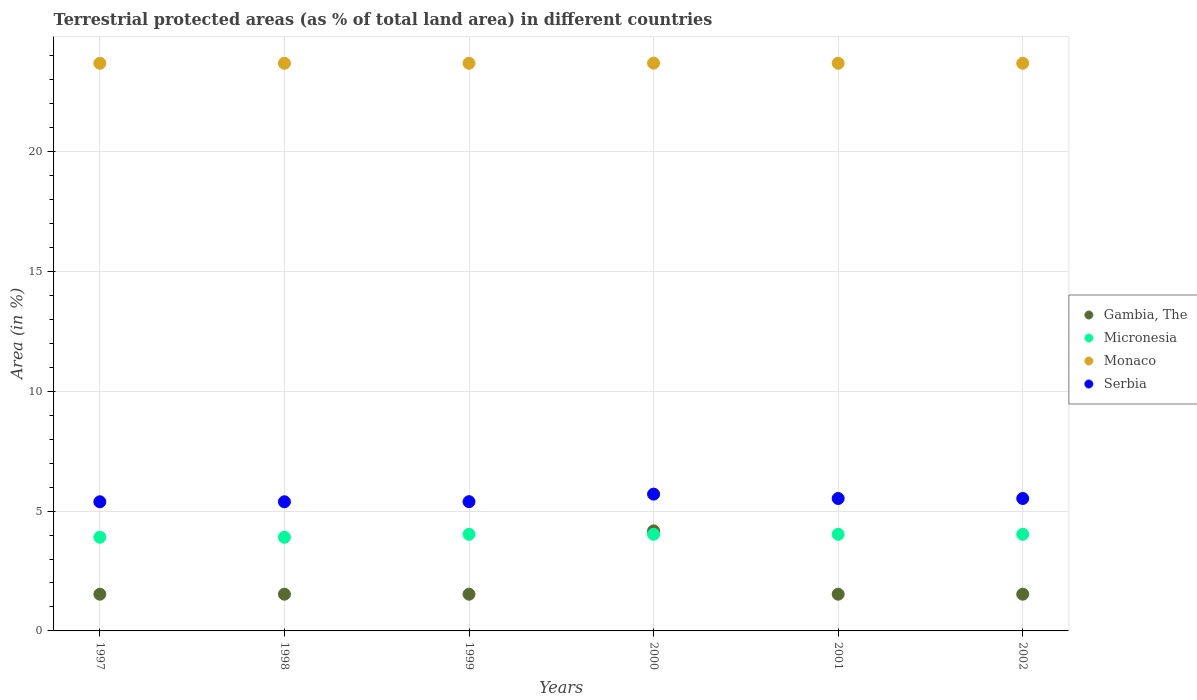What is the percentage of terrestrial protected land in Serbia in 2000?
Provide a short and direct response. 5.71. Across all years, what is the maximum percentage of terrestrial protected land in Micronesia?
Your response must be concise. 4.03. Across all years, what is the minimum percentage of terrestrial protected land in Micronesia?
Your answer should be compact. 3.91. In which year was the percentage of terrestrial protected land in Monaco maximum?
Keep it short and to the point. 2000. What is the total percentage of terrestrial protected land in Gambia, The in the graph?
Give a very brief answer. 11.84. What is the difference between the percentage of terrestrial protected land in Monaco in 2000 and that in 2001?
Provide a succinct answer. 0.01. What is the difference between the percentage of terrestrial protected land in Monaco in 1998 and the percentage of terrestrial protected land in Micronesia in 2002?
Ensure brevity in your answer.  19.65. What is the average percentage of terrestrial protected land in Monaco per year?
Give a very brief answer. 23.69. In the year 2001, what is the difference between the percentage of terrestrial protected land in Monaco and percentage of terrestrial protected land in Gambia, The?
Make the answer very short. 22.15. What is the ratio of the percentage of terrestrial protected land in Serbia in 1998 to that in 2000?
Make the answer very short. 0.94. Is the percentage of terrestrial protected land in Monaco in 1997 less than that in 2001?
Offer a terse response. No. Is the difference between the percentage of terrestrial protected land in Monaco in 1997 and 1998 greater than the difference between the percentage of terrestrial protected land in Gambia, The in 1997 and 1998?
Provide a short and direct response. No. What is the difference between the highest and the second highest percentage of terrestrial protected land in Gambia, The?
Offer a terse response. 2.64. What is the difference between the highest and the lowest percentage of terrestrial protected land in Serbia?
Your answer should be very brief. 0.32. In how many years, is the percentage of terrestrial protected land in Monaco greater than the average percentage of terrestrial protected land in Monaco taken over all years?
Give a very brief answer. 1. Is the sum of the percentage of terrestrial protected land in Micronesia in 1999 and 2001 greater than the maximum percentage of terrestrial protected land in Monaco across all years?
Provide a short and direct response. No. Is the percentage of terrestrial protected land in Serbia strictly less than the percentage of terrestrial protected land in Gambia, The over the years?
Give a very brief answer. No. How many dotlines are there?
Your answer should be very brief. 4. Does the graph contain any zero values?
Offer a very short reply. No. How are the legend labels stacked?
Provide a succinct answer. Vertical. What is the title of the graph?
Ensure brevity in your answer.  Terrestrial protected areas (as % of total land area) in different countries. Does "Egypt, Arab Rep." appear as one of the legend labels in the graph?
Offer a terse response. No. What is the label or title of the X-axis?
Offer a terse response. Years. What is the label or title of the Y-axis?
Keep it short and to the point. Area (in %). What is the Area (in %) in Gambia, The in 1997?
Your response must be concise. 1.53. What is the Area (in %) of Micronesia in 1997?
Your answer should be compact. 3.91. What is the Area (in %) in Monaco in 1997?
Your answer should be very brief. 23.68. What is the Area (in %) in Serbia in 1997?
Provide a short and direct response. 5.39. What is the Area (in %) of Gambia, The in 1998?
Provide a succinct answer. 1.53. What is the Area (in %) in Micronesia in 1998?
Keep it short and to the point. 3.91. What is the Area (in %) in Monaco in 1998?
Give a very brief answer. 23.68. What is the Area (in %) of Serbia in 1998?
Provide a succinct answer. 5.39. What is the Area (in %) in Gambia, The in 1999?
Your answer should be very brief. 1.53. What is the Area (in %) of Micronesia in 1999?
Give a very brief answer. 4.03. What is the Area (in %) of Monaco in 1999?
Your answer should be very brief. 23.68. What is the Area (in %) in Serbia in 1999?
Your response must be concise. 5.39. What is the Area (in %) of Gambia, The in 2000?
Your answer should be very brief. 4.17. What is the Area (in %) in Micronesia in 2000?
Provide a short and direct response. 4.03. What is the Area (in %) in Monaco in 2000?
Offer a terse response. 23.69. What is the Area (in %) in Serbia in 2000?
Your answer should be very brief. 5.71. What is the Area (in %) of Gambia, The in 2001?
Provide a succinct answer. 1.53. What is the Area (in %) in Micronesia in 2001?
Your response must be concise. 4.03. What is the Area (in %) in Monaco in 2001?
Offer a terse response. 23.68. What is the Area (in %) of Serbia in 2001?
Provide a succinct answer. 5.53. What is the Area (in %) in Gambia, The in 2002?
Provide a short and direct response. 1.53. What is the Area (in %) of Micronesia in 2002?
Provide a succinct answer. 4.03. What is the Area (in %) of Monaco in 2002?
Offer a terse response. 23.68. What is the Area (in %) of Serbia in 2002?
Provide a succinct answer. 5.53. Across all years, what is the maximum Area (in %) of Gambia, The?
Your response must be concise. 4.17. Across all years, what is the maximum Area (in %) of Micronesia?
Your answer should be very brief. 4.03. Across all years, what is the maximum Area (in %) of Monaco?
Your answer should be compact. 23.69. Across all years, what is the maximum Area (in %) of Serbia?
Ensure brevity in your answer.  5.71. Across all years, what is the minimum Area (in %) in Gambia, The?
Ensure brevity in your answer.  1.53. Across all years, what is the minimum Area (in %) in Micronesia?
Offer a very short reply. 3.91. Across all years, what is the minimum Area (in %) in Monaco?
Make the answer very short. 23.68. Across all years, what is the minimum Area (in %) of Serbia?
Give a very brief answer. 5.39. What is the total Area (in %) of Gambia, The in the graph?
Keep it short and to the point. 11.84. What is the total Area (in %) of Micronesia in the graph?
Keep it short and to the point. 23.94. What is the total Area (in %) in Monaco in the graph?
Make the answer very short. 142.11. What is the total Area (in %) of Serbia in the graph?
Provide a short and direct response. 32.93. What is the difference between the Area (in %) of Serbia in 1997 and that in 1998?
Keep it short and to the point. -0. What is the difference between the Area (in %) in Micronesia in 1997 and that in 1999?
Make the answer very short. -0.12. What is the difference between the Area (in %) of Monaco in 1997 and that in 1999?
Ensure brevity in your answer.  0. What is the difference between the Area (in %) in Serbia in 1997 and that in 1999?
Ensure brevity in your answer.  -0. What is the difference between the Area (in %) in Gambia, The in 1997 and that in 2000?
Provide a short and direct response. -2.64. What is the difference between the Area (in %) of Micronesia in 1997 and that in 2000?
Ensure brevity in your answer.  -0.12. What is the difference between the Area (in %) in Monaco in 1997 and that in 2000?
Ensure brevity in your answer.  -0.01. What is the difference between the Area (in %) of Serbia in 1997 and that in 2000?
Your answer should be compact. -0.32. What is the difference between the Area (in %) in Gambia, The in 1997 and that in 2001?
Ensure brevity in your answer.  0. What is the difference between the Area (in %) in Micronesia in 1997 and that in 2001?
Keep it short and to the point. -0.12. What is the difference between the Area (in %) of Serbia in 1997 and that in 2001?
Offer a very short reply. -0.14. What is the difference between the Area (in %) of Gambia, The in 1997 and that in 2002?
Make the answer very short. 0. What is the difference between the Area (in %) of Micronesia in 1997 and that in 2002?
Your response must be concise. -0.12. What is the difference between the Area (in %) of Serbia in 1997 and that in 2002?
Offer a terse response. -0.14. What is the difference between the Area (in %) of Micronesia in 1998 and that in 1999?
Offer a very short reply. -0.12. What is the difference between the Area (in %) in Monaco in 1998 and that in 1999?
Ensure brevity in your answer.  0. What is the difference between the Area (in %) of Serbia in 1998 and that in 1999?
Make the answer very short. -0. What is the difference between the Area (in %) of Gambia, The in 1998 and that in 2000?
Your response must be concise. -2.64. What is the difference between the Area (in %) of Micronesia in 1998 and that in 2000?
Your response must be concise. -0.12. What is the difference between the Area (in %) in Monaco in 1998 and that in 2000?
Provide a short and direct response. -0.01. What is the difference between the Area (in %) in Serbia in 1998 and that in 2000?
Ensure brevity in your answer.  -0.32. What is the difference between the Area (in %) of Micronesia in 1998 and that in 2001?
Keep it short and to the point. -0.12. What is the difference between the Area (in %) of Monaco in 1998 and that in 2001?
Offer a very short reply. 0. What is the difference between the Area (in %) of Serbia in 1998 and that in 2001?
Keep it short and to the point. -0.14. What is the difference between the Area (in %) in Micronesia in 1998 and that in 2002?
Give a very brief answer. -0.12. What is the difference between the Area (in %) of Monaco in 1998 and that in 2002?
Ensure brevity in your answer.  0. What is the difference between the Area (in %) in Serbia in 1998 and that in 2002?
Offer a terse response. -0.14. What is the difference between the Area (in %) in Gambia, The in 1999 and that in 2000?
Your response must be concise. -2.64. What is the difference between the Area (in %) of Monaco in 1999 and that in 2000?
Your answer should be compact. -0.01. What is the difference between the Area (in %) of Serbia in 1999 and that in 2000?
Offer a terse response. -0.31. What is the difference between the Area (in %) of Gambia, The in 1999 and that in 2001?
Provide a short and direct response. 0. What is the difference between the Area (in %) in Monaco in 1999 and that in 2001?
Ensure brevity in your answer.  0. What is the difference between the Area (in %) in Serbia in 1999 and that in 2001?
Make the answer very short. -0.13. What is the difference between the Area (in %) in Gambia, The in 1999 and that in 2002?
Your response must be concise. 0. What is the difference between the Area (in %) of Serbia in 1999 and that in 2002?
Ensure brevity in your answer.  -0.13. What is the difference between the Area (in %) in Gambia, The in 2000 and that in 2001?
Offer a terse response. 2.64. What is the difference between the Area (in %) in Micronesia in 2000 and that in 2001?
Your response must be concise. -0. What is the difference between the Area (in %) of Monaco in 2000 and that in 2001?
Make the answer very short. 0.01. What is the difference between the Area (in %) in Serbia in 2000 and that in 2001?
Provide a short and direct response. 0.18. What is the difference between the Area (in %) in Gambia, The in 2000 and that in 2002?
Your response must be concise. 2.64. What is the difference between the Area (in %) in Micronesia in 2000 and that in 2002?
Keep it short and to the point. -0. What is the difference between the Area (in %) of Monaco in 2000 and that in 2002?
Keep it short and to the point. 0.01. What is the difference between the Area (in %) in Serbia in 2000 and that in 2002?
Offer a very short reply. 0.18. What is the difference between the Area (in %) in Monaco in 2001 and that in 2002?
Provide a succinct answer. 0. What is the difference between the Area (in %) in Gambia, The in 1997 and the Area (in %) in Micronesia in 1998?
Your answer should be very brief. -2.38. What is the difference between the Area (in %) in Gambia, The in 1997 and the Area (in %) in Monaco in 1998?
Your response must be concise. -22.15. What is the difference between the Area (in %) of Gambia, The in 1997 and the Area (in %) of Serbia in 1998?
Give a very brief answer. -3.86. What is the difference between the Area (in %) in Micronesia in 1997 and the Area (in %) in Monaco in 1998?
Offer a very short reply. -19.78. What is the difference between the Area (in %) of Micronesia in 1997 and the Area (in %) of Serbia in 1998?
Keep it short and to the point. -1.48. What is the difference between the Area (in %) in Monaco in 1997 and the Area (in %) in Serbia in 1998?
Your response must be concise. 18.3. What is the difference between the Area (in %) of Gambia, The in 1997 and the Area (in %) of Micronesia in 1999?
Make the answer very short. -2.5. What is the difference between the Area (in %) in Gambia, The in 1997 and the Area (in %) in Monaco in 1999?
Make the answer very short. -22.15. What is the difference between the Area (in %) of Gambia, The in 1997 and the Area (in %) of Serbia in 1999?
Offer a very short reply. -3.86. What is the difference between the Area (in %) in Micronesia in 1997 and the Area (in %) in Monaco in 1999?
Ensure brevity in your answer.  -19.78. What is the difference between the Area (in %) of Micronesia in 1997 and the Area (in %) of Serbia in 1999?
Provide a succinct answer. -1.48. What is the difference between the Area (in %) of Monaco in 1997 and the Area (in %) of Serbia in 1999?
Provide a short and direct response. 18.29. What is the difference between the Area (in %) in Gambia, The in 1997 and the Area (in %) in Micronesia in 2000?
Your response must be concise. -2.5. What is the difference between the Area (in %) of Gambia, The in 1997 and the Area (in %) of Monaco in 2000?
Your response must be concise. -22.16. What is the difference between the Area (in %) in Gambia, The in 1997 and the Area (in %) in Serbia in 2000?
Ensure brevity in your answer.  -4.18. What is the difference between the Area (in %) in Micronesia in 1997 and the Area (in %) in Monaco in 2000?
Provide a short and direct response. -19.78. What is the difference between the Area (in %) in Micronesia in 1997 and the Area (in %) in Serbia in 2000?
Provide a short and direct response. -1.8. What is the difference between the Area (in %) of Monaco in 1997 and the Area (in %) of Serbia in 2000?
Provide a short and direct response. 17.98. What is the difference between the Area (in %) of Gambia, The in 1997 and the Area (in %) of Micronesia in 2001?
Provide a short and direct response. -2.5. What is the difference between the Area (in %) of Gambia, The in 1997 and the Area (in %) of Monaco in 2001?
Your answer should be compact. -22.15. What is the difference between the Area (in %) in Gambia, The in 1997 and the Area (in %) in Serbia in 2001?
Give a very brief answer. -3.99. What is the difference between the Area (in %) in Micronesia in 1997 and the Area (in %) in Monaco in 2001?
Offer a terse response. -19.78. What is the difference between the Area (in %) in Micronesia in 1997 and the Area (in %) in Serbia in 2001?
Your answer should be compact. -1.62. What is the difference between the Area (in %) of Monaco in 1997 and the Area (in %) of Serbia in 2001?
Ensure brevity in your answer.  18.16. What is the difference between the Area (in %) in Gambia, The in 1997 and the Area (in %) in Micronesia in 2002?
Offer a very short reply. -2.5. What is the difference between the Area (in %) in Gambia, The in 1997 and the Area (in %) in Monaco in 2002?
Give a very brief answer. -22.15. What is the difference between the Area (in %) of Gambia, The in 1997 and the Area (in %) of Serbia in 2002?
Offer a terse response. -3.99. What is the difference between the Area (in %) of Micronesia in 1997 and the Area (in %) of Monaco in 2002?
Your response must be concise. -19.78. What is the difference between the Area (in %) of Micronesia in 1997 and the Area (in %) of Serbia in 2002?
Ensure brevity in your answer.  -1.62. What is the difference between the Area (in %) in Monaco in 1997 and the Area (in %) in Serbia in 2002?
Give a very brief answer. 18.16. What is the difference between the Area (in %) in Gambia, The in 1998 and the Area (in %) in Micronesia in 1999?
Offer a terse response. -2.5. What is the difference between the Area (in %) in Gambia, The in 1998 and the Area (in %) in Monaco in 1999?
Your answer should be very brief. -22.15. What is the difference between the Area (in %) in Gambia, The in 1998 and the Area (in %) in Serbia in 1999?
Provide a succinct answer. -3.86. What is the difference between the Area (in %) of Micronesia in 1998 and the Area (in %) of Monaco in 1999?
Keep it short and to the point. -19.78. What is the difference between the Area (in %) in Micronesia in 1998 and the Area (in %) in Serbia in 1999?
Offer a very short reply. -1.48. What is the difference between the Area (in %) in Monaco in 1998 and the Area (in %) in Serbia in 1999?
Keep it short and to the point. 18.29. What is the difference between the Area (in %) of Gambia, The in 1998 and the Area (in %) of Micronesia in 2000?
Ensure brevity in your answer.  -2.5. What is the difference between the Area (in %) in Gambia, The in 1998 and the Area (in %) in Monaco in 2000?
Offer a terse response. -22.16. What is the difference between the Area (in %) in Gambia, The in 1998 and the Area (in %) in Serbia in 2000?
Keep it short and to the point. -4.18. What is the difference between the Area (in %) in Micronesia in 1998 and the Area (in %) in Monaco in 2000?
Make the answer very short. -19.78. What is the difference between the Area (in %) of Micronesia in 1998 and the Area (in %) of Serbia in 2000?
Ensure brevity in your answer.  -1.8. What is the difference between the Area (in %) of Monaco in 1998 and the Area (in %) of Serbia in 2000?
Your answer should be very brief. 17.98. What is the difference between the Area (in %) of Gambia, The in 1998 and the Area (in %) of Micronesia in 2001?
Provide a short and direct response. -2.5. What is the difference between the Area (in %) in Gambia, The in 1998 and the Area (in %) in Monaco in 2001?
Offer a terse response. -22.15. What is the difference between the Area (in %) in Gambia, The in 1998 and the Area (in %) in Serbia in 2001?
Provide a succinct answer. -3.99. What is the difference between the Area (in %) in Micronesia in 1998 and the Area (in %) in Monaco in 2001?
Keep it short and to the point. -19.78. What is the difference between the Area (in %) in Micronesia in 1998 and the Area (in %) in Serbia in 2001?
Your answer should be compact. -1.62. What is the difference between the Area (in %) of Monaco in 1998 and the Area (in %) of Serbia in 2001?
Your answer should be compact. 18.16. What is the difference between the Area (in %) of Gambia, The in 1998 and the Area (in %) of Micronesia in 2002?
Your answer should be very brief. -2.5. What is the difference between the Area (in %) in Gambia, The in 1998 and the Area (in %) in Monaco in 2002?
Ensure brevity in your answer.  -22.15. What is the difference between the Area (in %) in Gambia, The in 1998 and the Area (in %) in Serbia in 2002?
Your answer should be compact. -3.99. What is the difference between the Area (in %) of Micronesia in 1998 and the Area (in %) of Monaco in 2002?
Make the answer very short. -19.78. What is the difference between the Area (in %) of Micronesia in 1998 and the Area (in %) of Serbia in 2002?
Keep it short and to the point. -1.62. What is the difference between the Area (in %) in Monaco in 1998 and the Area (in %) in Serbia in 2002?
Your answer should be compact. 18.16. What is the difference between the Area (in %) in Gambia, The in 1999 and the Area (in %) in Micronesia in 2000?
Keep it short and to the point. -2.5. What is the difference between the Area (in %) in Gambia, The in 1999 and the Area (in %) in Monaco in 2000?
Your answer should be very brief. -22.16. What is the difference between the Area (in %) of Gambia, The in 1999 and the Area (in %) of Serbia in 2000?
Your answer should be very brief. -4.18. What is the difference between the Area (in %) of Micronesia in 1999 and the Area (in %) of Monaco in 2000?
Your answer should be compact. -19.66. What is the difference between the Area (in %) in Micronesia in 1999 and the Area (in %) in Serbia in 2000?
Provide a succinct answer. -1.68. What is the difference between the Area (in %) of Monaco in 1999 and the Area (in %) of Serbia in 2000?
Offer a very short reply. 17.98. What is the difference between the Area (in %) in Gambia, The in 1999 and the Area (in %) in Micronesia in 2001?
Provide a succinct answer. -2.5. What is the difference between the Area (in %) in Gambia, The in 1999 and the Area (in %) in Monaco in 2001?
Your answer should be compact. -22.15. What is the difference between the Area (in %) of Gambia, The in 1999 and the Area (in %) of Serbia in 2001?
Offer a terse response. -3.99. What is the difference between the Area (in %) in Micronesia in 1999 and the Area (in %) in Monaco in 2001?
Offer a very short reply. -19.65. What is the difference between the Area (in %) in Micronesia in 1999 and the Area (in %) in Serbia in 2001?
Provide a succinct answer. -1.49. What is the difference between the Area (in %) of Monaco in 1999 and the Area (in %) of Serbia in 2001?
Give a very brief answer. 18.16. What is the difference between the Area (in %) of Gambia, The in 1999 and the Area (in %) of Micronesia in 2002?
Make the answer very short. -2.5. What is the difference between the Area (in %) in Gambia, The in 1999 and the Area (in %) in Monaco in 2002?
Your response must be concise. -22.15. What is the difference between the Area (in %) in Gambia, The in 1999 and the Area (in %) in Serbia in 2002?
Ensure brevity in your answer.  -3.99. What is the difference between the Area (in %) of Micronesia in 1999 and the Area (in %) of Monaco in 2002?
Ensure brevity in your answer.  -19.65. What is the difference between the Area (in %) of Micronesia in 1999 and the Area (in %) of Serbia in 2002?
Your answer should be very brief. -1.49. What is the difference between the Area (in %) of Monaco in 1999 and the Area (in %) of Serbia in 2002?
Ensure brevity in your answer.  18.16. What is the difference between the Area (in %) in Gambia, The in 2000 and the Area (in %) in Micronesia in 2001?
Ensure brevity in your answer.  0.14. What is the difference between the Area (in %) of Gambia, The in 2000 and the Area (in %) of Monaco in 2001?
Ensure brevity in your answer.  -19.51. What is the difference between the Area (in %) of Gambia, The in 2000 and the Area (in %) of Serbia in 2001?
Provide a short and direct response. -1.35. What is the difference between the Area (in %) in Micronesia in 2000 and the Area (in %) in Monaco in 2001?
Offer a very short reply. -19.65. What is the difference between the Area (in %) of Micronesia in 2000 and the Area (in %) of Serbia in 2001?
Ensure brevity in your answer.  -1.49. What is the difference between the Area (in %) of Monaco in 2000 and the Area (in %) of Serbia in 2001?
Make the answer very short. 18.16. What is the difference between the Area (in %) of Gambia, The in 2000 and the Area (in %) of Micronesia in 2002?
Provide a short and direct response. 0.14. What is the difference between the Area (in %) of Gambia, The in 2000 and the Area (in %) of Monaco in 2002?
Provide a succinct answer. -19.51. What is the difference between the Area (in %) of Gambia, The in 2000 and the Area (in %) of Serbia in 2002?
Your answer should be very brief. -1.35. What is the difference between the Area (in %) in Micronesia in 2000 and the Area (in %) in Monaco in 2002?
Ensure brevity in your answer.  -19.65. What is the difference between the Area (in %) of Micronesia in 2000 and the Area (in %) of Serbia in 2002?
Offer a terse response. -1.49. What is the difference between the Area (in %) in Monaco in 2000 and the Area (in %) in Serbia in 2002?
Offer a terse response. 18.16. What is the difference between the Area (in %) in Gambia, The in 2001 and the Area (in %) in Micronesia in 2002?
Offer a terse response. -2.5. What is the difference between the Area (in %) of Gambia, The in 2001 and the Area (in %) of Monaco in 2002?
Provide a short and direct response. -22.15. What is the difference between the Area (in %) of Gambia, The in 2001 and the Area (in %) of Serbia in 2002?
Make the answer very short. -3.99. What is the difference between the Area (in %) of Micronesia in 2001 and the Area (in %) of Monaco in 2002?
Ensure brevity in your answer.  -19.65. What is the difference between the Area (in %) in Micronesia in 2001 and the Area (in %) in Serbia in 2002?
Ensure brevity in your answer.  -1.49. What is the difference between the Area (in %) of Monaco in 2001 and the Area (in %) of Serbia in 2002?
Offer a terse response. 18.16. What is the average Area (in %) of Gambia, The per year?
Provide a short and direct response. 1.97. What is the average Area (in %) of Micronesia per year?
Provide a succinct answer. 3.99. What is the average Area (in %) in Monaco per year?
Make the answer very short. 23.69. What is the average Area (in %) in Serbia per year?
Give a very brief answer. 5.49. In the year 1997, what is the difference between the Area (in %) in Gambia, The and Area (in %) in Micronesia?
Offer a terse response. -2.38. In the year 1997, what is the difference between the Area (in %) in Gambia, The and Area (in %) in Monaco?
Your response must be concise. -22.15. In the year 1997, what is the difference between the Area (in %) in Gambia, The and Area (in %) in Serbia?
Offer a terse response. -3.86. In the year 1997, what is the difference between the Area (in %) of Micronesia and Area (in %) of Monaco?
Offer a very short reply. -19.78. In the year 1997, what is the difference between the Area (in %) in Micronesia and Area (in %) in Serbia?
Offer a very short reply. -1.48. In the year 1997, what is the difference between the Area (in %) in Monaco and Area (in %) in Serbia?
Your response must be concise. 18.3. In the year 1998, what is the difference between the Area (in %) of Gambia, The and Area (in %) of Micronesia?
Offer a very short reply. -2.38. In the year 1998, what is the difference between the Area (in %) of Gambia, The and Area (in %) of Monaco?
Offer a very short reply. -22.15. In the year 1998, what is the difference between the Area (in %) in Gambia, The and Area (in %) in Serbia?
Offer a terse response. -3.86. In the year 1998, what is the difference between the Area (in %) in Micronesia and Area (in %) in Monaco?
Offer a very short reply. -19.78. In the year 1998, what is the difference between the Area (in %) of Micronesia and Area (in %) of Serbia?
Offer a terse response. -1.48. In the year 1998, what is the difference between the Area (in %) in Monaco and Area (in %) in Serbia?
Your answer should be very brief. 18.3. In the year 1999, what is the difference between the Area (in %) in Gambia, The and Area (in %) in Micronesia?
Provide a succinct answer. -2.5. In the year 1999, what is the difference between the Area (in %) in Gambia, The and Area (in %) in Monaco?
Provide a short and direct response. -22.15. In the year 1999, what is the difference between the Area (in %) in Gambia, The and Area (in %) in Serbia?
Keep it short and to the point. -3.86. In the year 1999, what is the difference between the Area (in %) of Micronesia and Area (in %) of Monaco?
Keep it short and to the point. -19.65. In the year 1999, what is the difference between the Area (in %) in Micronesia and Area (in %) in Serbia?
Ensure brevity in your answer.  -1.36. In the year 1999, what is the difference between the Area (in %) in Monaco and Area (in %) in Serbia?
Ensure brevity in your answer.  18.29. In the year 2000, what is the difference between the Area (in %) in Gambia, The and Area (in %) in Micronesia?
Offer a terse response. 0.14. In the year 2000, what is the difference between the Area (in %) in Gambia, The and Area (in %) in Monaco?
Provide a short and direct response. -19.52. In the year 2000, what is the difference between the Area (in %) of Gambia, The and Area (in %) of Serbia?
Keep it short and to the point. -1.53. In the year 2000, what is the difference between the Area (in %) of Micronesia and Area (in %) of Monaco?
Provide a short and direct response. -19.66. In the year 2000, what is the difference between the Area (in %) in Micronesia and Area (in %) in Serbia?
Provide a succinct answer. -1.68. In the year 2000, what is the difference between the Area (in %) in Monaco and Area (in %) in Serbia?
Offer a terse response. 17.98. In the year 2001, what is the difference between the Area (in %) of Gambia, The and Area (in %) of Micronesia?
Provide a short and direct response. -2.5. In the year 2001, what is the difference between the Area (in %) in Gambia, The and Area (in %) in Monaco?
Your response must be concise. -22.15. In the year 2001, what is the difference between the Area (in %) in Gambia, The and Area (in %) in Serbia?
Provide a short and direct response. -3.99. In the year 2001, what is the difference between the Area (in %) in Micronesia and Area (in %) in Monaco?
Keep it short and to the point. -19.65. In the year 2001, what is the difference between the Area (in %) of Micronesia and Area (in %) of Serbia?
Offer a very short reply. -1.49. In the year 2001, what is the difference between the Area (in %) of Monaco and Area (in %) of Serbia?
Ensure brevity in your answer.  18.16. In the year 2002, what is the difference between the Area (in %) of Gambia, The and Area (in %) of Micronesia?
Make the answer very short. -2.5. In the year 2002, what is the difference between the Area (in %) in Gambia, The and Area (in %) in Monaco?
Your answer should be very brief. -22.15. In the year 2002, what is the difference between the Area (in %) of Gambia, The and Area (in %) of Serbia?
Give a very brief answer. -3.99. In the year 2002, what is the difference between the Area (in %) in Micronesia and Area (in %) in Monaco?
Keep it short and to the point. -19.65. In the year 2002, what is the difference between the Area (in %) in Micronesia and Area (in %) in Serbia?
Your answer should be very brief. -1.49. In the year 2002, what is the difference between the Area (in %) of Monaco and Area (in %) of Serbia?
Offer a very short reply. 18.16. What is the ratio of the Area (in %) of Gambia, The in 1997 to that in 1998?
Keep it short and to the point. 1. What is the ratio of the Area (in %) of Micronesia in 1997 to that in 1998?
Keep it short and to the point. 1. What is the ratio of the Area (in %) of Gambia, The in 1997 to that in 1999?
Your answer should be compact. 1. What is the ratio of the Area (in %) in Micronesia in 1997 to that in 1999?
Provide a succinct answer. 0.97. What is the ratio of the Area (in %) of Gambia, The in 1997 to that in 2000?
Your answer should be very brief. 0.37. What is the ratio of the Area (in %) of Micronesia in 1997 to that in 2000?
Keep it short and to the point. 0.97. What is the ratio of the Area (in %) in Monaco in 1997 to that in 2000?
Your response must be concise. 1. What is the ratio of the Area (in %) in Serbia in 1997 to that in 2000?
Your response must be concise. 0.94. What is the ratio of the Area (in %) in Gambia, The in 1997 to that in 2001?
Offer a terse response. 1. What is the ratio of the Area (in %) in Micronesia in 1997 to that in 2001?
Provide a succinct answer. 0.97. What is the ratio of the Area (in %) of Monaco in 1997 to that in 2001?
Ensure brevity in your answer.  1. What is the ratio of the Area (in %) in Serbia in 1997 to that in 2001?
Provide a succinct answer. 0.98. What is the ratio of the Area (in %) in Gambia, The in 1997 to that in 2002?
Offer a very short reply. 1. What is the ratio of the Area (in %) in Micronesia in 1997 to that in 2002?
Give a very brief answer. 0.97. What is the ratio of the Area (in %) in Serbia in 1997 to that in 2002?
Offer a terse response. 0.98. What is the ratio of the Area (in %) of Gambia, The in 1998 to that in 1999?
Your answer should be very brief. 1. What is the ratio of the Area (in %) of Micronesia in 1998 to that in 1999?
Your response must be concise. 0.97. What is the ratio of the Area (in %) of Serbia in 1998 to that in 1999?
Give a very brief answer. 1. What is the ratio of the Area (in %) of Gambia, The in 1998 to that in 2000?
Offer a very short reply. 0.37. What is the ratio of the Area (in %) of Micronesia in 1998 to that in 2000?
Ensure brevity in your answer.  0.97. What is the ratio of the Area (in %) of Monaco in 1998 to that in 2000?
Keep it short and to the point. 1. What is the ratio of the Area (in %) of Serbia in 1998 to that in 2000?
Offer a terse response. 0.94. What is the ratio of the Area (in %) of Micronesia in 1998 to that in 2001?
Your response must be concise. 0.97. What is the ratio of the Area (in %) of Serbia in 1998 to that in 2001?
Make the answer very short. 0.98. What is the ratio of the Area (in %) of Gambia, The in 1998 to that in 2002?
Make the answer very short. 1. What is the ratio of the Area (in %) of Micronesia in 1998 to that in 2002?
Give a very brief answer. 0.97. What is the ratio of the Area (in %) of Serbia in 1998 to that in 2002?
Offer a terse response. 0.98. What is the ratio of the Area (in %) of Gambia, The in 1999 to that in 2000?
Offer a very short reply. 0.37. What is the ratio of the Area (in %) of Serbia in 1999 to that in 2000?
Make the answer very short. 0.94. What is the ratio of the Area (in %) in Micronesia in 1999 to that in 2001?
Make the answer very short. 1. What is the ratio of the Area (in %) of Monaco in 1999 to that in 2001?
Give a very brief answer. 1. What is the ratio of the Area (in %) in Gambia, The in 1999 to that in 2002?
Give a very brief answer. 1. What is the ratio of the Area (in %) of Monaco in 1999 to that in 2002?
Ensure brevity in your answer.  1. What is the ratio of the Area (in %) of Serbia in 1999 to that in 2002?
Keep it short and to the point. 0.98. What is the ratio of the Area (in %) in Gambia, The in 2000 to that in 2001?
Your answer should be very brief. 2.72. What is the ratio of the Area (in %) of Serbia in 2000 to that in 2001?
Your answer should be compact. 1.03. What is the ratio of the Area (in %) in Gambia, The in 2000 to that in 2002?
Your response must be concise. 2.72. What is the ratio of the Area (in %) in Monaco in 2000 to that in 2002?
Offer a terse response. 1. What is the ratio of the Area (in %) of Serbia in 2000 to that in 2002?
Offer a very short reply. 1.03. What is the ratio of the Area (in %) in Micronesia in 2001 to that in 2002?
Provide a short and direct response. 1. What is the ratio of the Area (in %) of Serbia in 2001 to that in 2002?
Your answer should be compact. 1. What is the difference between the highest and the second highest Area (in %) of Gambia, The?
Keep it short and to the point. 2.64. What is the difference between the highest and the second highest Area (in %) in Monaco?
Offer a very short reply. 0.01. What is the difference between the highest and the second highest Area (in %) in Serbia?
Your answer should be compact. 0.18. What is the difference between the highest and the lowest Area (in %) in Gambia, The?
Offer a very short reply. 2.64. What is the difference between the highest and the lowest Area (in %) in Micronesia?
Ensure brevity in your answer.  0.12. What is the difference between the highest and the lowest Area (in %) of Monaco?
Keep it short and to the point. 0.01. What is the difference between the highest and the lowest Area (in %) of Serbia?
Keep it short and to the point. 0.32. 